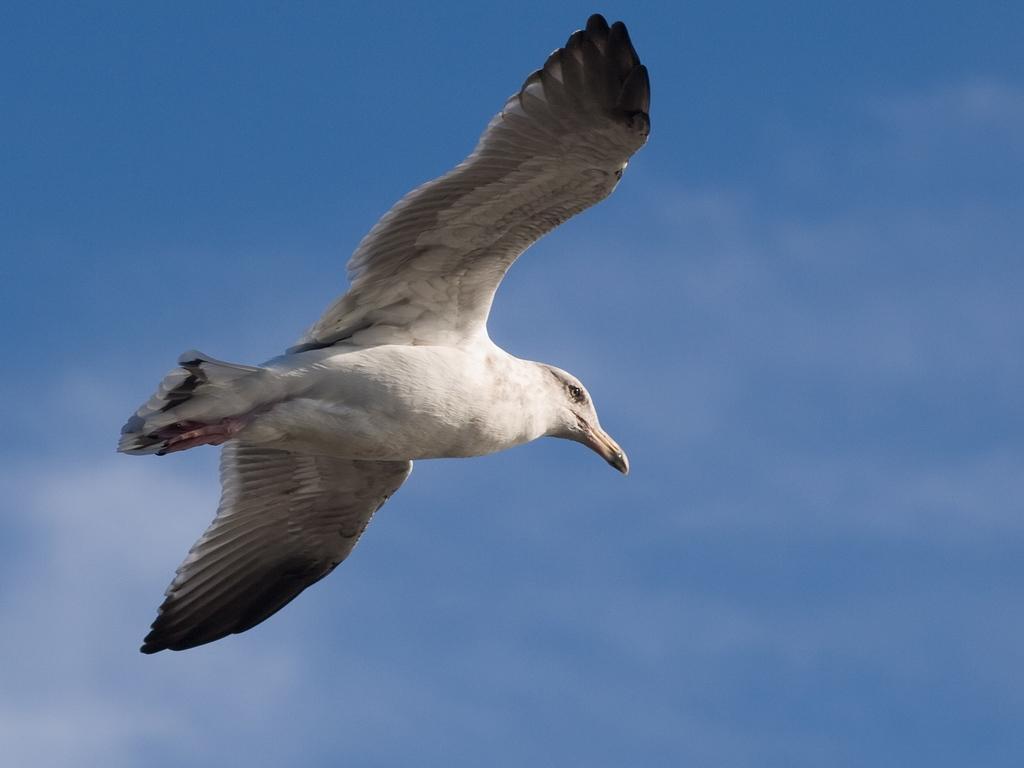How would you summarize this image in a sentence or two? In this image we can see one bird flying in the sky. 